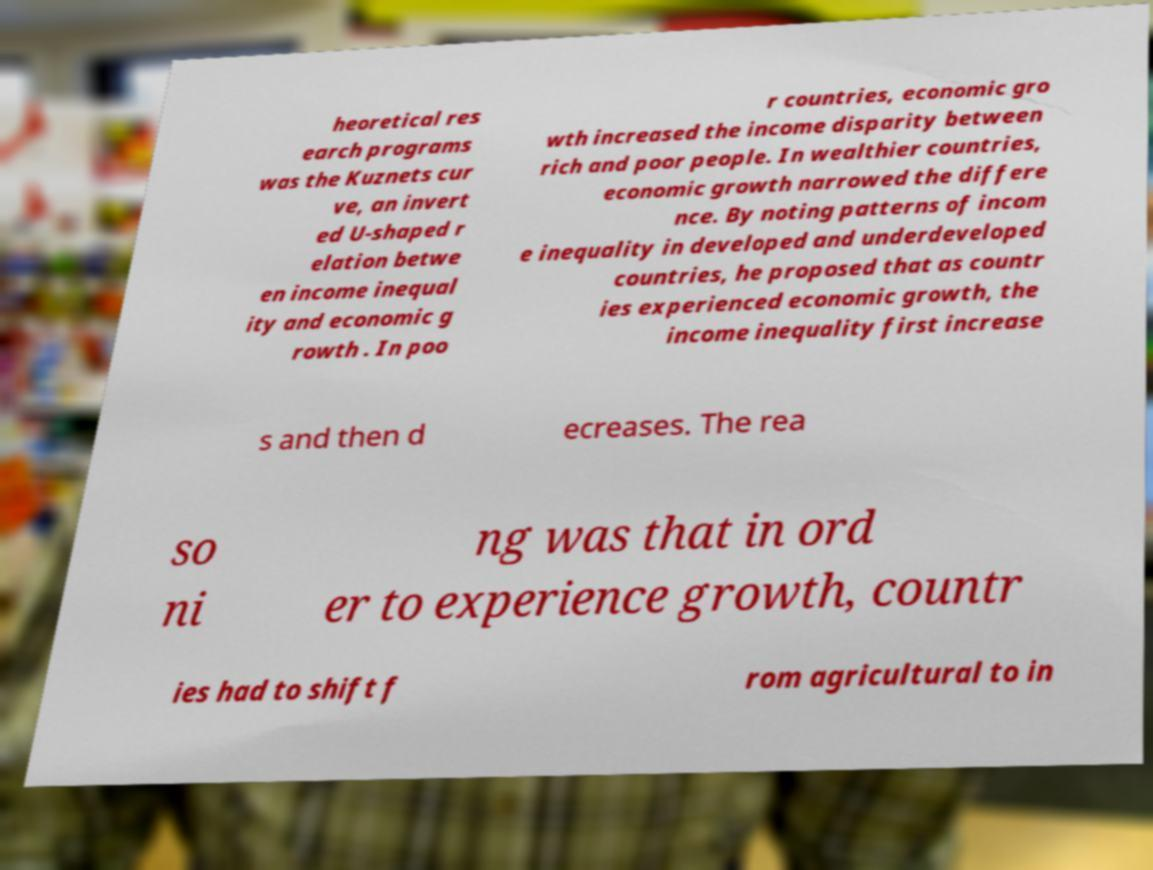For documentation purposes, I need the text within this image transcribed. Could you provide that? heoretical res earch programs was the Kuznets cur ve, an invert ed U-shaped r elation betwe en income inequal ity and economic g rowth . In poo r countries, economic gro wth increased the income disparity between rich and poor people. In wealthier countries, economic growth narrowed the differe nce. By noting patterns of incom e inequality in developed and underdeveloped countries, he proposed that as countr ies experienced economic growth, the income inequality first increase s and then d ecreases. The rea so ni ng was that in ord er to experience growth, countr ies had to shift f rom agricultural to in 